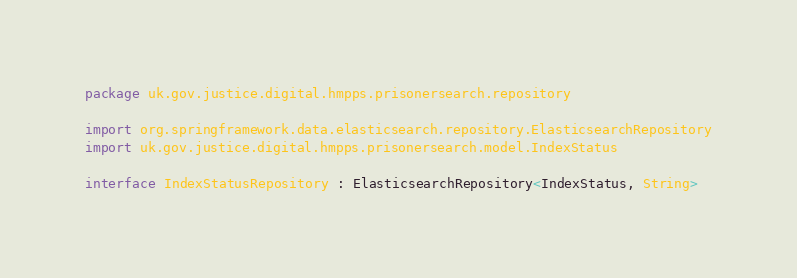Convert code to text. <code><loc_0><loc_0><loc_500><loc_500><_Kotlin_>package uk.gov.justice.digital.hmpps.prisonersearch.repository

import org.springframework.data.elasticsearch.repository.ElasticsearchRepository
import uk.gov.justice.digital.hmpps.prisonersearch.model.IndexStatus

interface IndexStatusRepository : ElasticsearchRepository<IndexStatus, String>
</code> 